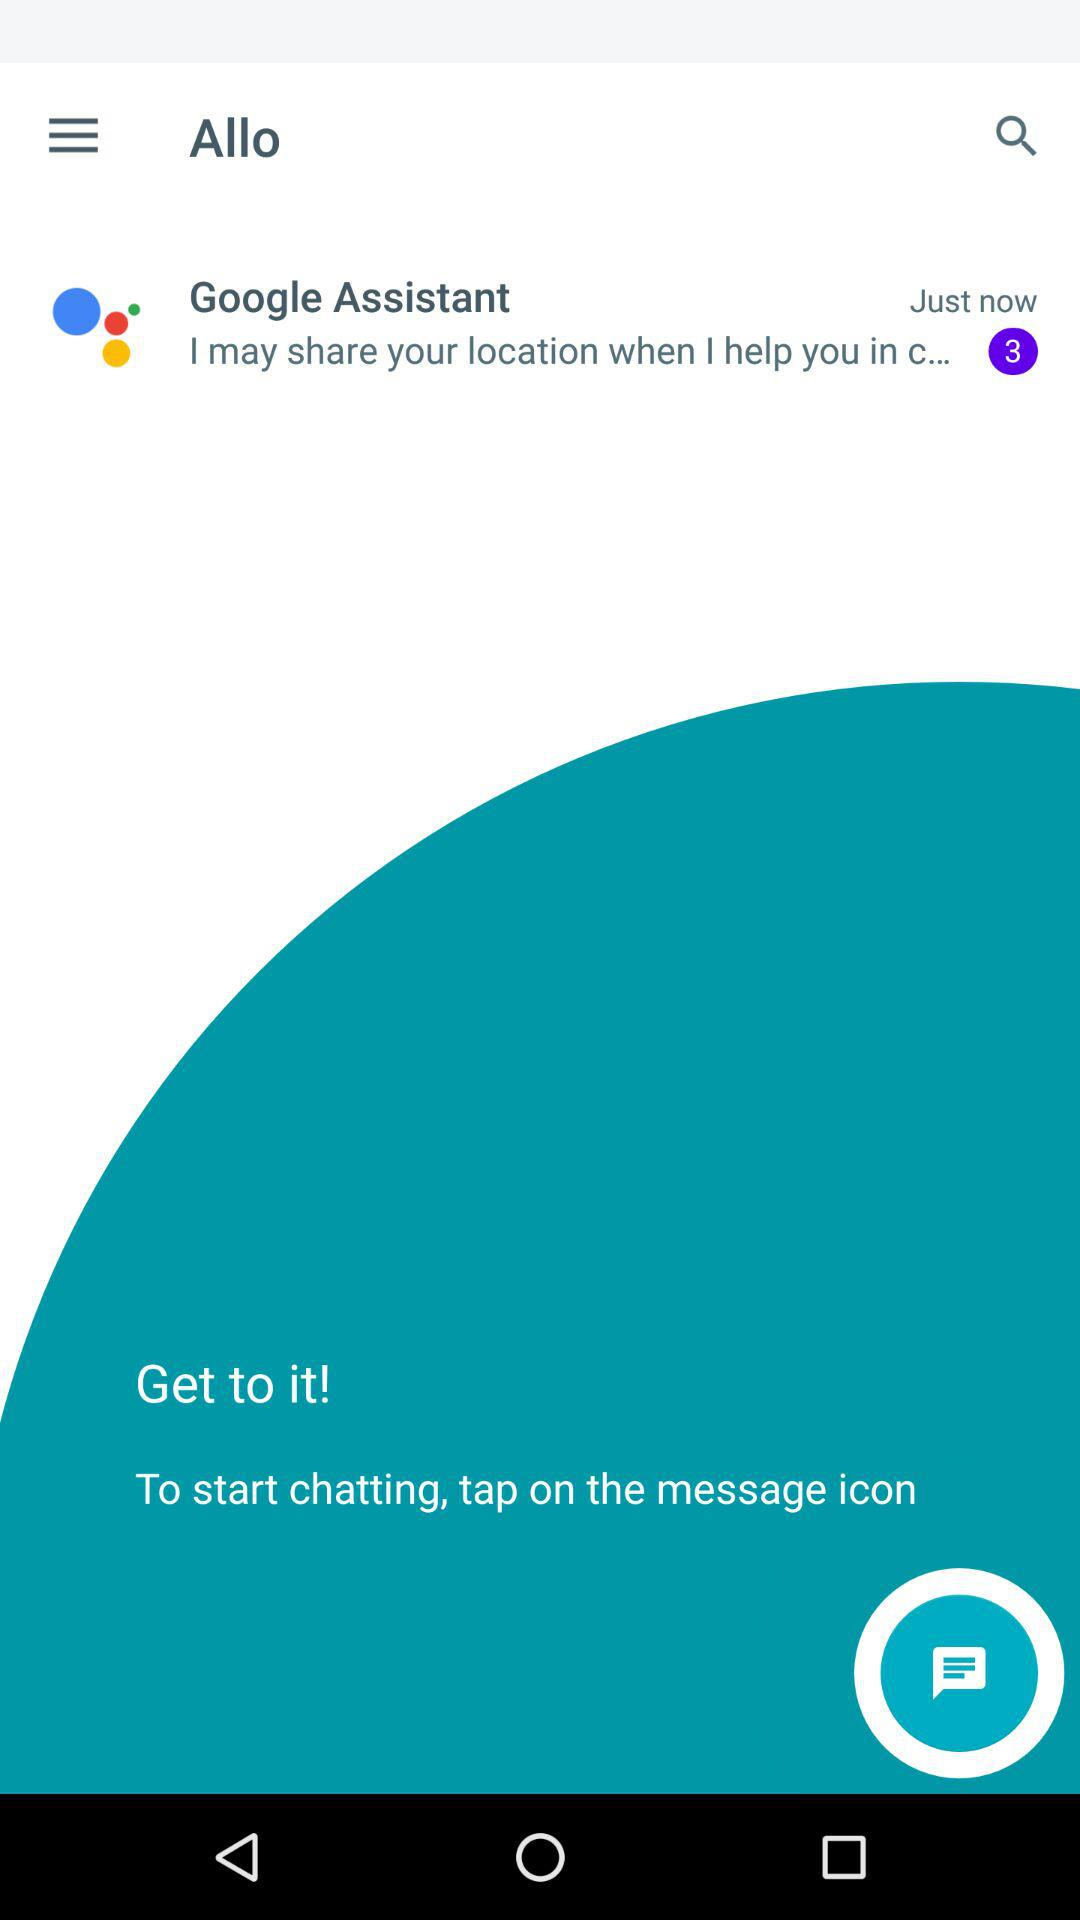How many notifications are pending on Google Assistant? There are 3 pending notifications. 